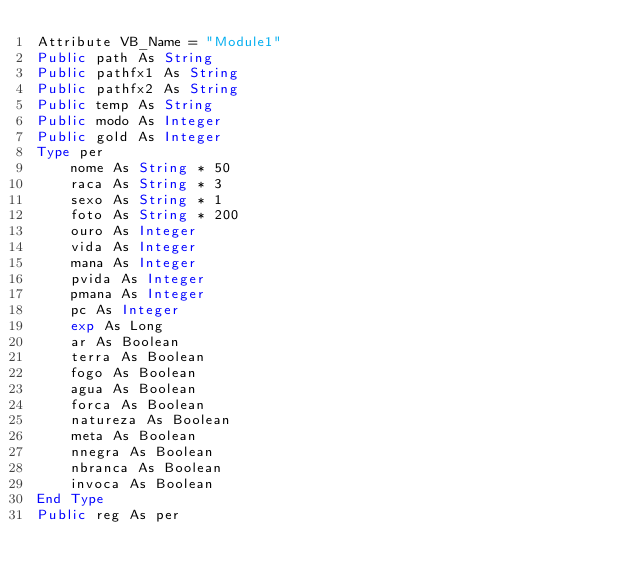Convert code to text. <code><loc_0><loc_0><loc_500><loc_500><_VisualBasic_>Attribute VB_Name = "Module1"
Public path As String
Public pathfx1 As String
Public pathfx2 As String
Public temp As String
Public modo As Integer
Public gold As Integer
Type per
    nome As String * 50
    raca As String * 3
    sexo As String * 1
    foto As String * 200
    ouro As Integer
    vida As Integer
    mana As Integer
    pvida As Integer
    pmana As Integer
    pc As Integer
    exp As Long
    ar As Boolean
    terra As Boolean
    fogo As Boolean
    agua As Boolean
    forca As Boolean
    natureza As Boolean
    meta As Boolean
    nnegra As Boolean
    nbranca As Boolean
    invoca As Boolean
End Type
Public reg As per
</code> 